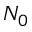<formula> <loc_0><loc_0><loc_500><loc_500>N _ { 0 }</formula> 